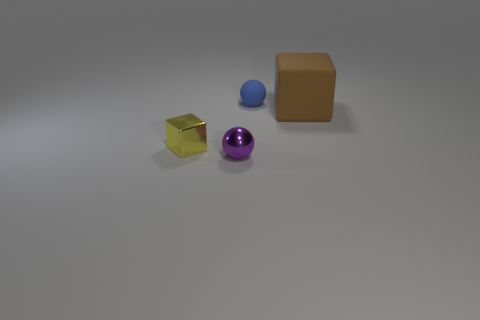Are there any small cubes that are behind the brown rubber thing that is to the right of the tiny object that is in front of the small yellow thing? no 